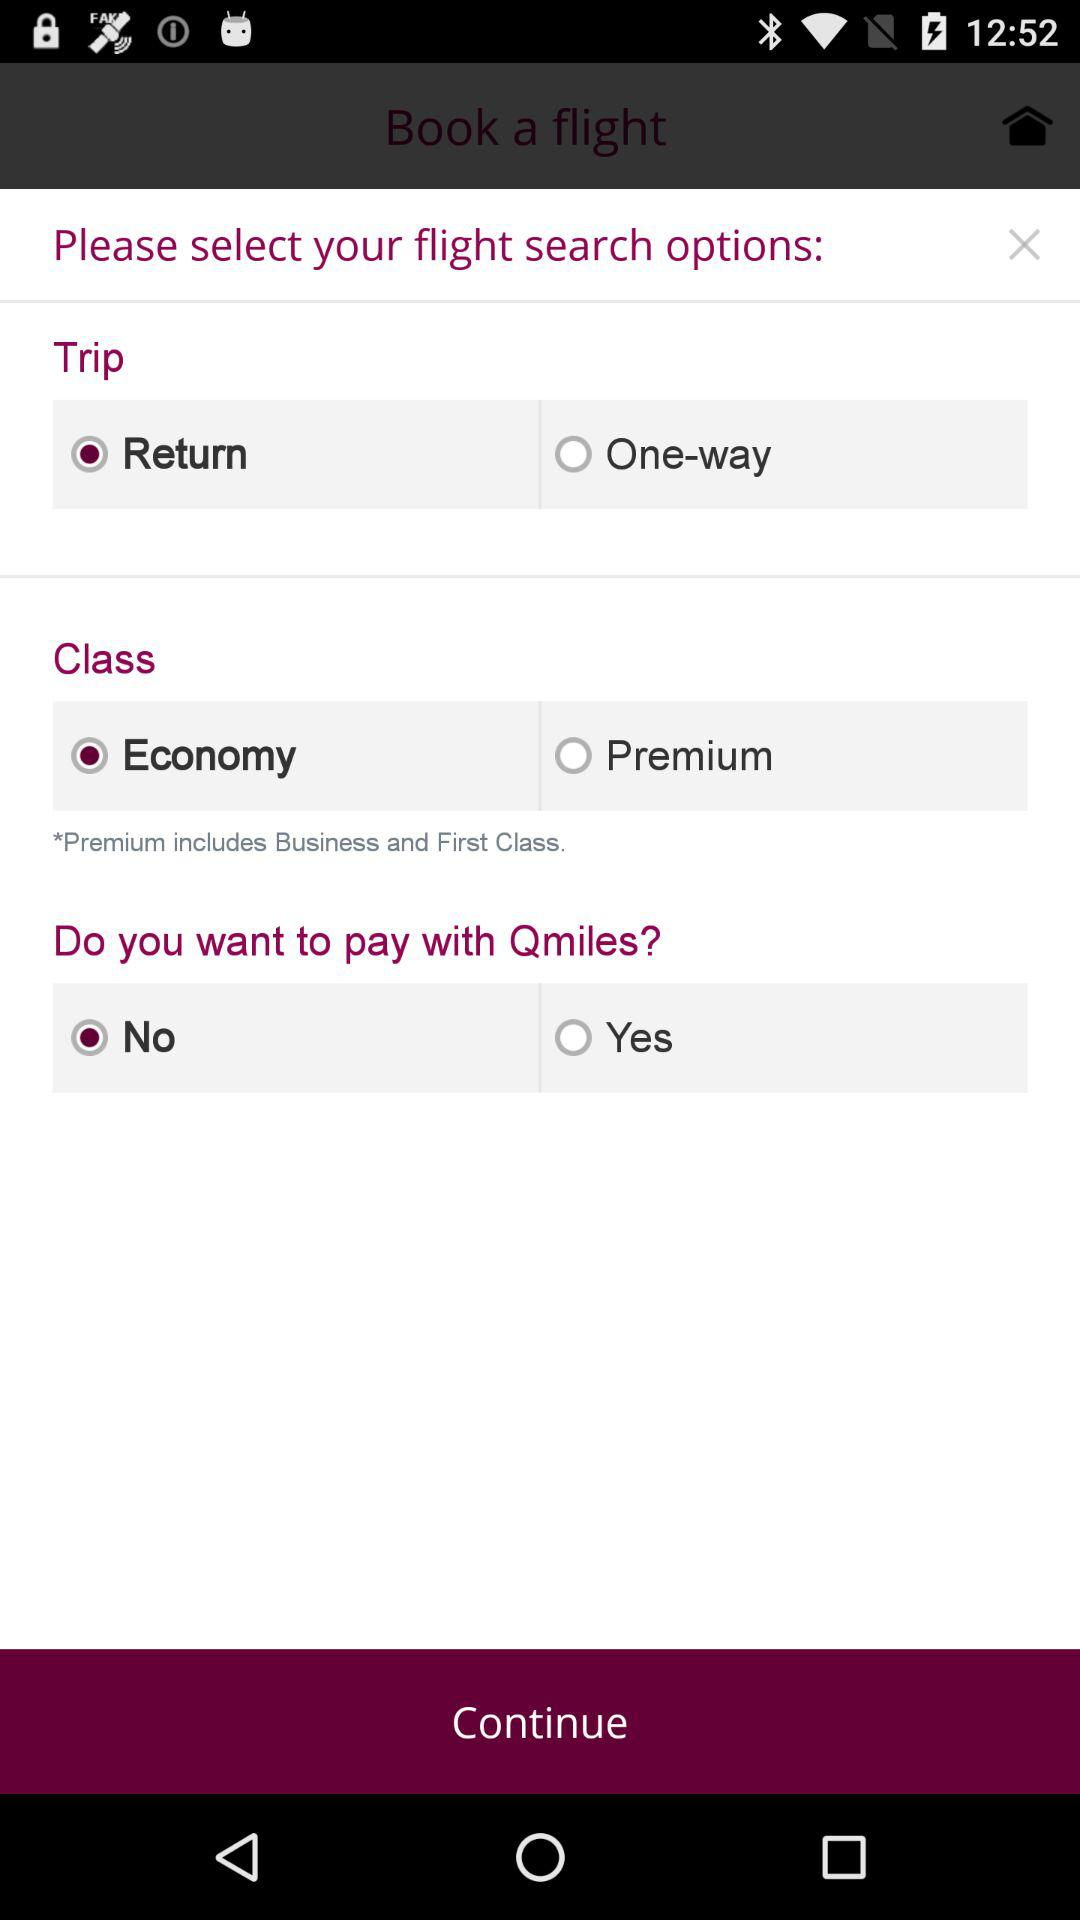What classes are included in the premium? Premium includes Business and First Class. 